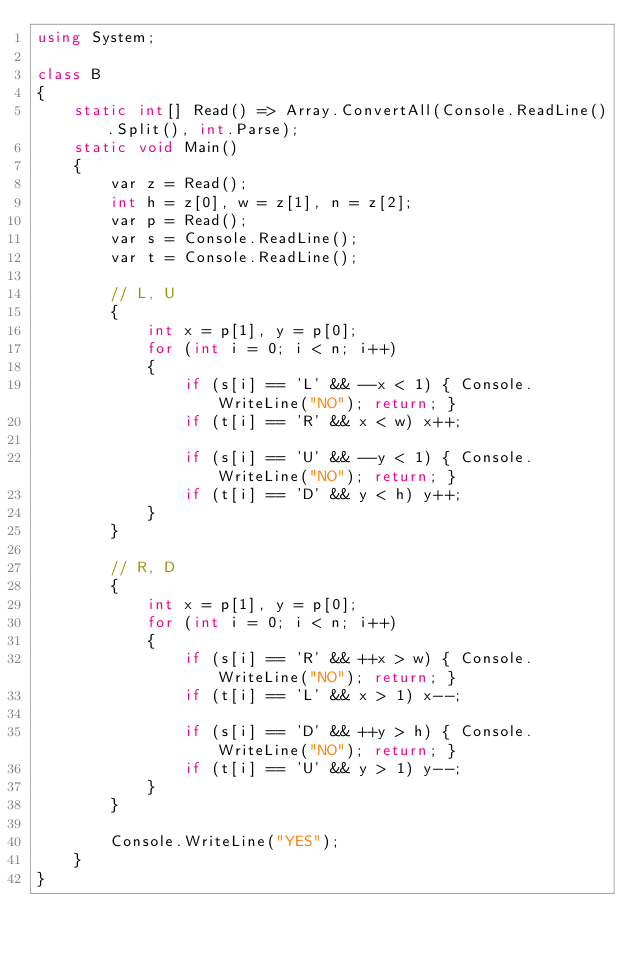<code> <loc_0><loc_0><loc_500><loc_500><_C#_>using System;

class B
{
	static int[] Read() => Array.ConvertAll(Console.ReadLine().Split(), int.Parse);
	static void Main()
	{
		var z = Read();
		int h = z[0], w = z[1], n = z[2];
		var p = Read();
		var s = Console.ReadLine();
		var t = Console.ReadLine();

		// L, U
		{
			int x = p[1], y = p[0];
			for (int i = 0; i < n; i++)
			{
				if (s[i] == 'L' && --x < 1) { Console.WriteLine("NO"); return; }
				if (t[i] == 'R' && x < w) x++;

				if (s[i] == 'U' && --y < 1) { Console.WriteLine("NO"); return; }
				if (t[i] == 'D' && y < h) y++;
			}
		}

		// R, D
		{
			int x = p[1], y = p[0];
			for (int i = 0; i < n; i++)
			{
				if (s[i] == 'R' && ++x > w) { Console.WriteLine("NO"); return; }
				if (t[i] == 'L' && x > 1) x--;

				if (s[i] == 'D' && ++y > h) { Console.WriteLine("NO"); return; }
				if (t[i] == 'U' && y > 1) y--;
			}
		}

		Console.WriteLine("YES");
	}
}
</code> 